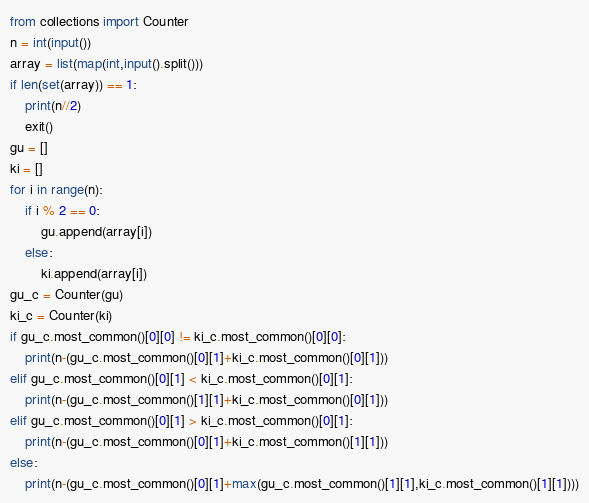<code> <loc_0><loc_0><loc_500><loc_500><_Python_>from collections import Counter
n = int(input())
array = list(map(int,input().split()))
if len(set(array)) == 1:
    print(n//2)
    exit()
gu = []
ki = []
for i in range(n):
    if i % 2 == 0:
        gu.append(array[i])
    else:
        ki.append(array[i])
gu_c = Counter(gu)
ki_c = Counter(ki)
if gu_c.most_common()[0][0] != ki_c.most_common()[0][0]:
    print(n-(gu_c.most_common()[0][1]+ki_c.most_common()[0][1]))
elif gu_c.most_common()[0][1] < ki_c.most_common()[0][1]:
    print(n-(gu_c.most_common()[1][1]+ki_c.most_common()[0][1]))
elif gu_c.most_common()[0][1] > ki_c.most_common()[0][1]:
    print(n-(gu_c.most_common()[0][1]+ki_c.most_common()[1][1]))
else:
    print(n-(gu_c.most_common()[0][1]+max(gu_c.most_common()[1][1],ki_c.most_common()[1][1])))</code> 